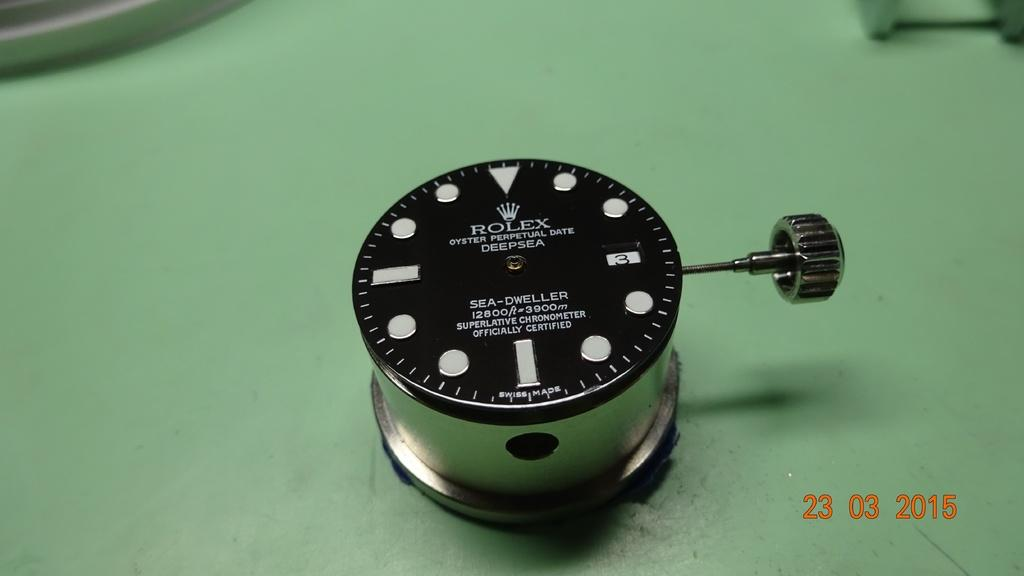<image>
Render a clear and concise summary of the photo. Face of a watch which has the word ROLEX in all white letters. 